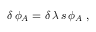<formula> <loc_0><loc_0><loc_500><loc_500>\delta \, \phi _ { A } = \delta \, \lambda \, s \, \phi _ { A } \, ,</formula> 